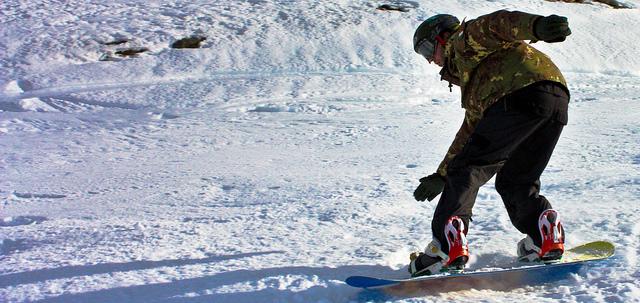How much snow is on the floor?
Quick response, please. Lot. What is on the ground?
Give a very brief answer. Snow. Why does the person lean forward?
Answer briefly. Balance. 